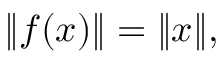Convert formula to latex. <formula><loc_0><loc_0><loc_500><loc_500>\| f ( x ) \| = \| x \| ,</formula> 